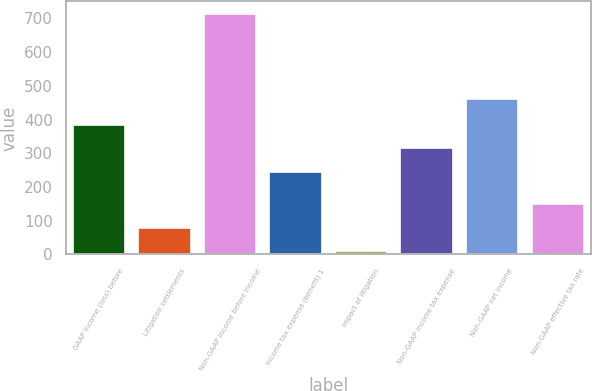Convert chart. <chart><loc_0><loc_0><loc_500><loc_500><bar_chart><fcel>GAAP income (loss) before<fcel>Litigation settlements<fcel>Non-GAAP income before income<fcel>Income tax expense (benefit) 1<fcel>Impact of litigation<fcel>Non-GAAP income tax expense<fcel>Non-GAAP net income<fcel>Non-GAAP effective tax rate<nl><fcel>385<fcel>79.5<fcel>714<fcel>244<fcel>9<fcel>314.5<fcel>461<fcel>150<nl></chart> 